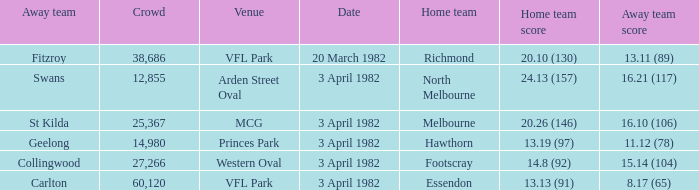What score did the home team of north melbourne get? 24.13 (157). 